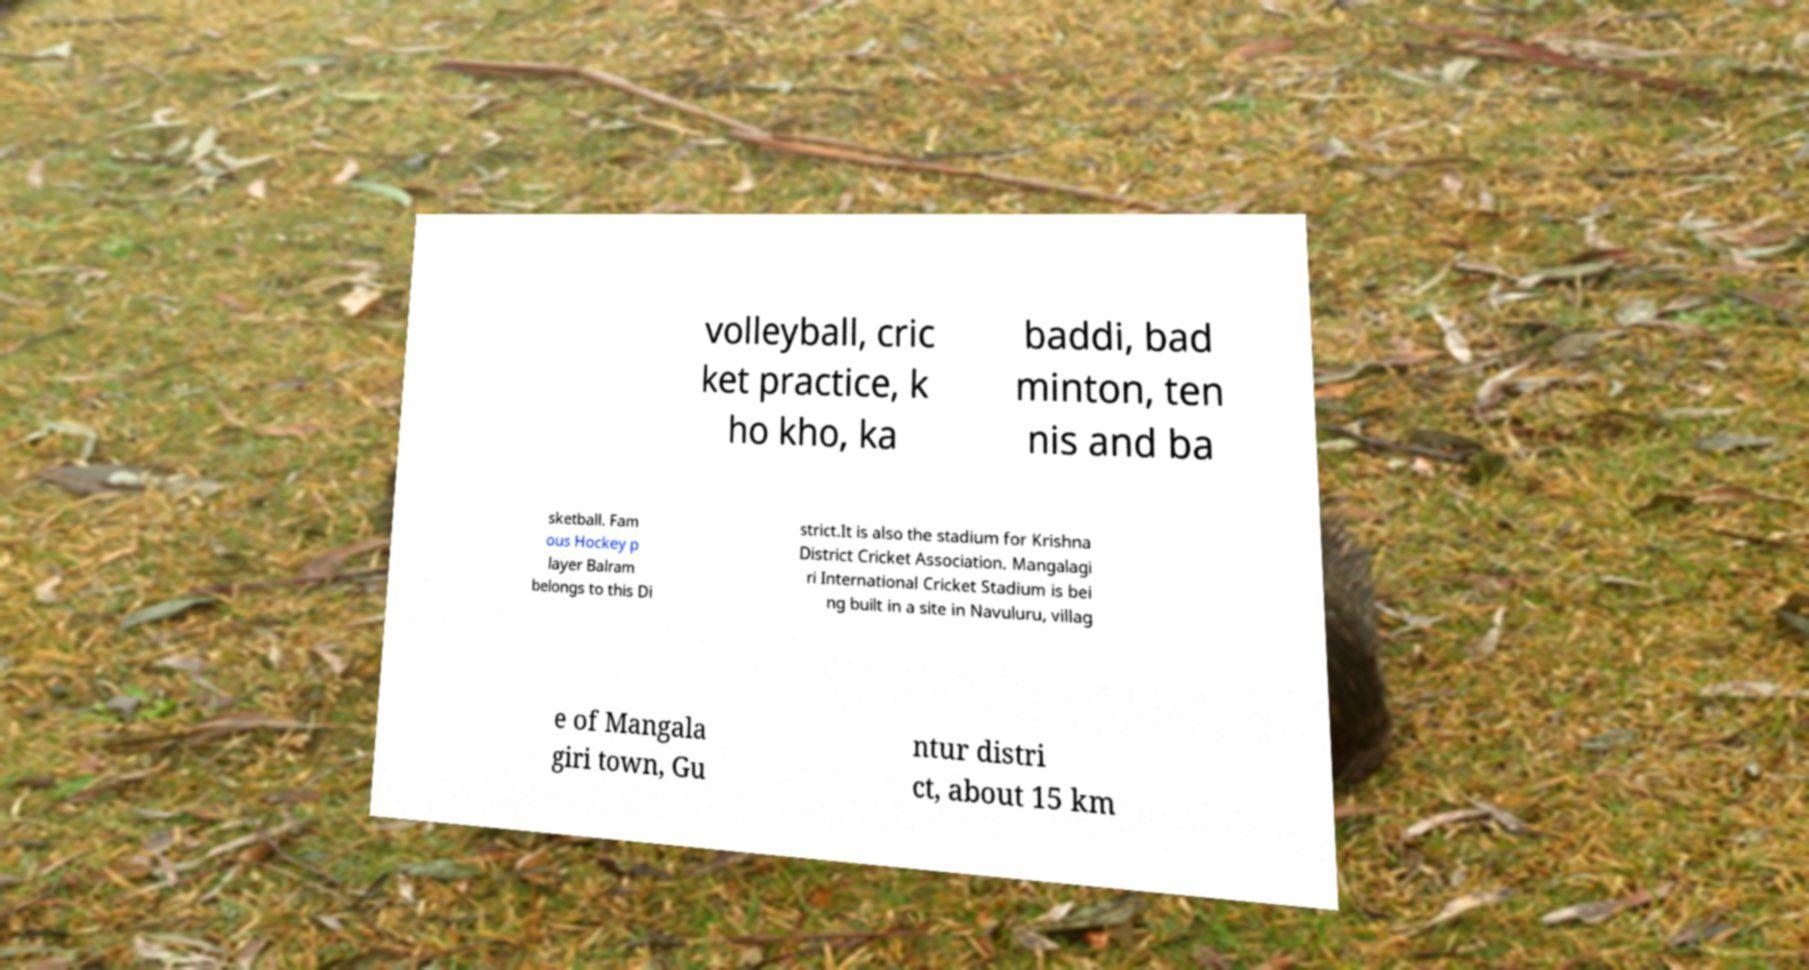Can you read and provide the text displayed in the image?This photo seems to have some interesting text. Can you extract and type it out for me? volleyball, cric ket practice, k ho kho, ka baddi, bad minton, ten nis and ba sketball. Fam ous Hockey p layer Balram belongs to this Di strict.It is also the stadium for Krishna District Cricket Association. Mangalagi ri International Cricket Stadium is bei ng built in a site in Navuluru, villag e of Mangala giri town, Gu ntur distri ct, about 15 km 